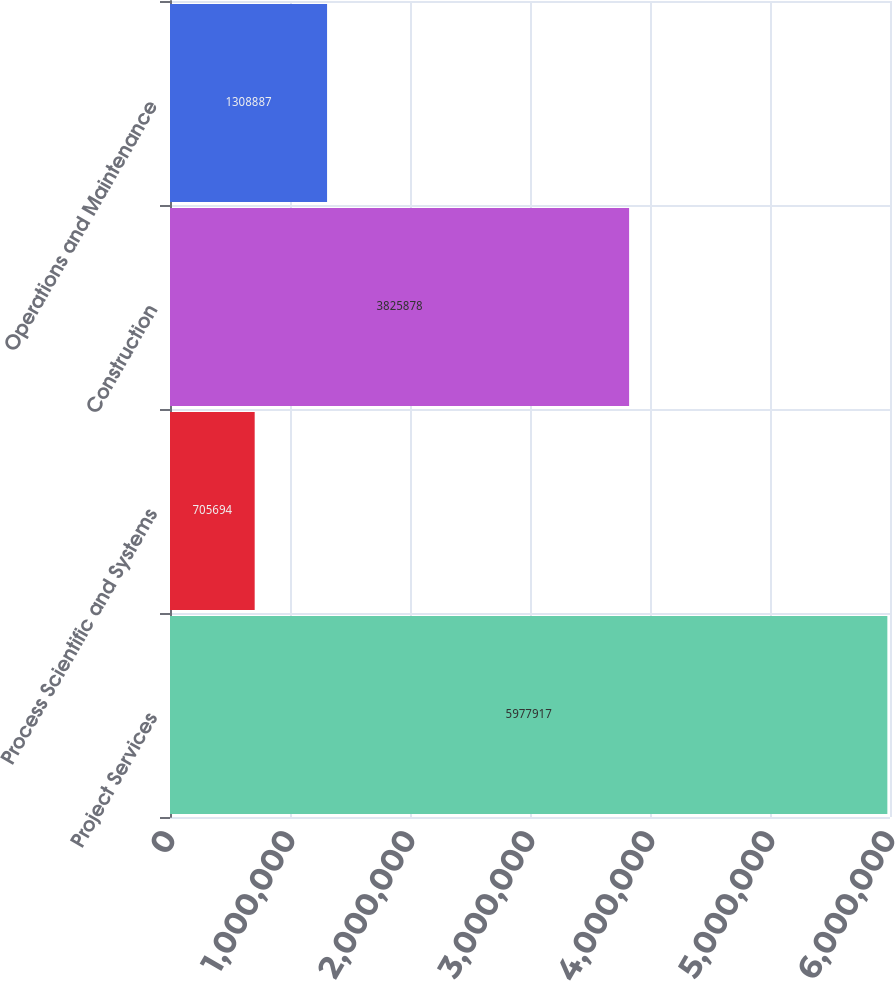<chart> <loc_0><loc_0><loc_500><loc_500><bar_chart><fcel>Project Services<fcel>Process Scientific and Systems<fcel>Construction<fcel>Operations and Maintenance<nl><fcel>5.97792e+06<fcel>705694<fcel>3.82588e+06<fcel>1.30889e+06<nl></chart> 